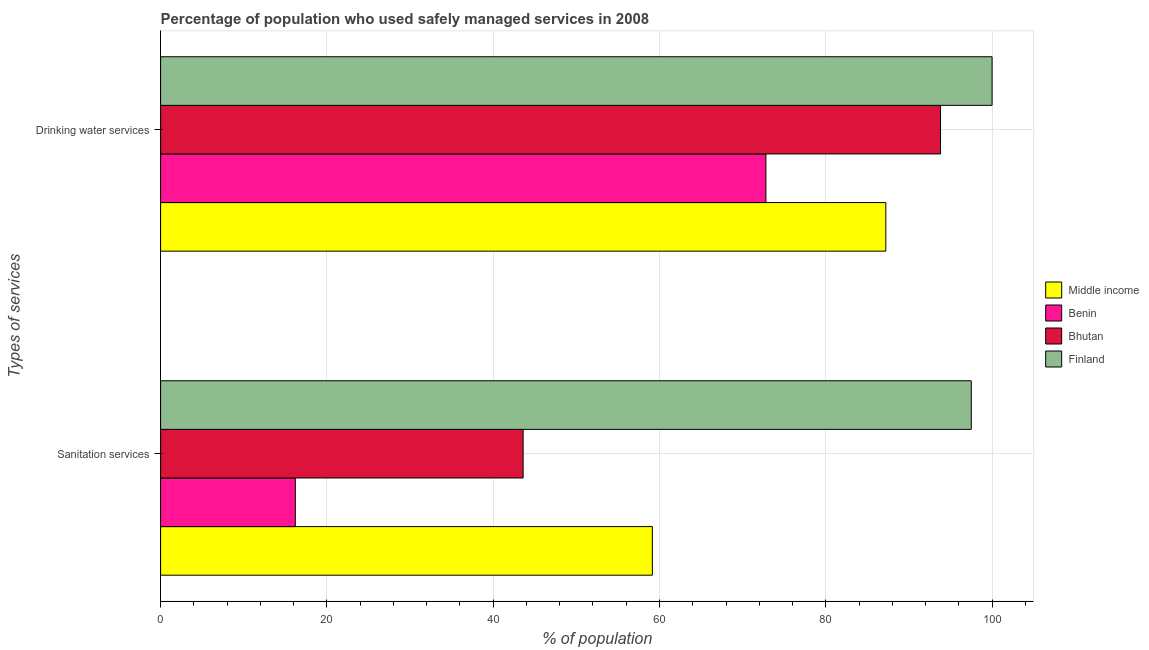How many groups of bars are there?
Give a very brief answer. 2. Are the number of bars per tick equal to the number of legend labels?
Provide a short and direct response. Yes. How many bars are there on the 1st tick from the bottom?
Provide a succinct answer. 4. What is the label of the 2nd group of bars from the top?
Offer a terse response. Sanitation services. What is the percentage of population who used drinking water services in Middle income?
Offer a terse response. 87.22. Across all countries, what is the maximum percentage of population who used sanitation services?
Ensure brevity in your answer.  97.5. In which country was the percentage of population who used sanitation services minimum?
Ensure brevity in your answer.  Benin. What is the total percentage of population who used drinking water services in the graph?
Provide a short and direct response. 353.82. What is the difference between the percentage of population who used drinking water services in Finland and the percentage of population who used sanitation services in Middle income?
Make the answer very short. 40.86. What is the average percentage of population who used drinking water services per country?
Keep it short and to the point. 88.45. What is the difference between the percentage of population who used drinking water services and percentage of population who used sanitation services in Benin?
Make the answer very short. 56.6. In how many countries, is the percentage of population who used sanitation services greater than 12 %?
Make the answer very short. 4. What is the ratio of the percentage of population who used drinking water services in Finland to that in Benin?
Your answer should be compact. 1.37. Is the percentage of population who used drinking water services in Finland less than that in Benin?
Make the answer very short. No. In how many countries, is the percentage of population who used sanitation services greater than the average percentage of population who used sanitation services taken over all countries?
Your answer should be compact. 2. How many bars are there?
Your answer should be very brief. 8. Are all the bars in the graph horizontal?
Your response must be concise. Yes. What is the difference between two consecutive major ticks on the X-axis?
Offer a very short reply. 20. Does the graph contain grids?
Offer a terse response. Yes. How many legend labels are there?
Your answer should be compact. 4. How are the legend labels stacked?
Offer a terse response. Vertical. What is the title of the graph?
Your response must be concise. Percentage of population who used safely managed services in 2008. What is the label or title of the X-axis?
Ensure brevity in your answer.  % of population. What is the label or title of the Y-axis?
Offer a very short reply. Types of services. What is the % of population in Middle income in Sanitation services?
Ensure brevity in your answer.  59.14. What is the % of population of Bhutan in Sanitation services?
Your answer should be compact. 43.6. What is the % of population of Finland in Sanitation services?
Your response must be concise. 97.5. What is the % of population in Middle income in Drinking water services?
Offer a very short reply. 87.22. What is the % of population in Benin in Drinking water services?
Make the answer very short. 72.8. What is the % of population in Bhutan in Drinking water services?
Your answer should be compact. 93.8. Across all Types of services, what is the maximum % of population of Middle income?
Keep it short and to the point. 87.22. Across all Types of services, what is the maximum % of population in Benin?
Make the answer very short. 72.8. Across all Types of services, what is the maximum % of population in Bhutan?
Your answer should be compact. 93.8. Across all Types of services, what is the maximum % of population in Finland?
Your response must be concise. 100. Across all Types of services, what is the minimum % of population in Middle income?
Keep it short and to the point. 59.14. Across all Types of services, what is the minimum % of population in Bhutan?
Your response must be concise. 43.6. Across all Types of services, what is the minimum % of population in Finland?
Keep it short and to the point. 97.5. What is the total % of population in Middle income in the graph?
Offer a terse response. 146.36. What is the total % of population in Benin in the graph?
Offer a terse response. 89. What is the total % of population of Bhutan in the graph?
Keep it short and to the point. 137.4. What is the total % of population in Finland in the graph?
Your response must be concise. 197.5. What is the difference between the % of population of Middle income in Sanitation services and that in Drinking water services?
Offer a terse response. -28.08. What is the difference between the % of population of Benin in Sanitation services and that in Drinking water services?
Make the answer very short. -56.6. What is the difference between the % of population of Bhutan in Sanitation services and that in Drinking water services?
Ensure brevity in your answer.  -50.2. What is the difference between the % of population in Middle income in Sanitation services and the % of population in Benin in Drinking water services?
Give a very brief answer. -13.66. What is the difference between the % of population in Middle income in Sanitation services and the % of population in Bhutan in Drinking water services?
Provide a short and direct response. -34.66. What is the difference between the % of population in Middle income in Sanitation services and the % of population in Finland in Drinking water services?
Provide a short and direct response. -40.86. What is the difference between the % of population in Benin in Sanitation services and the % of population in Bhutan in Drinking water services?
Your answer should be compact. -77.6. What is the difference between the % of population of Benin in Sanitation services and the % of population of Finland in Drinking water services?
Give a very brief answer. -83.8. What is the difference between the % of population of Bhutan in Sanitation services and the % of population of Finland in Drinking water services?
Keep it short and to the point. -56.4. What is the average % of population in Middle income per Types of services?
Your answer should be very brief. 73.18. What is the average % of population of Benin per Types of services?
Keep it short and to the point. 44.5. What is the average % of population in Bhutan per Types of services?
Ensure brevity in your answer.  68.7. What is the average % of population of Finland per Types of services?
Your response must be concise. 98.75. What is the difference between the % of population in Middle income and % of population in Benin in Sanitation services?
Your answer should be compact. 42.94. What is the difference between the % of population of Middle income and % of population of Bhutan in Sanitation services?
Provide a succinct answer. 15.54. What is the difference between the % of population in Middle income and % of population in Finland in Sanitation services?
Keep it short and to the point. -38.36. What is the difference between the % of population in Benin and % of population in Bhutan in Sanitation services?
Offer a very short reply. -27.4. What is the difference between the % of population of Benin and % of population of Finland in Sanitation services?
Keep it short and to the point. -81.3. What is the difference between the % of population of Bhutan and % of population of Finland in Sanitation services?
Ensure brevity in your answer.  -53.9. What is the difference between the % of population in Middle income and % of population in Benin in Drinking water services?
Provide a succinct answer. 14.42. What is the difference between the % of population of Middle income and % of population of Bhutan in Drinking water services?
Your response must be concise. -6.58. What is the difference between the % of population of Middle income and % of population of Finland in Drinking water services?
Your response must be concise. -12.78. What is the difference between the % of population in Benin and % of population in Bhutan in Drinking water services?
Provide a succinct answer. -21. What is the difference between the % of population of Benin and % of population of Finland in Drinking water services?
Ensure brevity in your answer.  -27.2. What is the ratio of the % of population of Middle income in Sanitation services to that in Drinking water services?
Provide a succinct answer. 0.68. What is the ratio of the % of population of Benin in Sanitation services to that in Drinking water services?
Give a very brief answer. 0.22. What is the ratio of the % of population in Bhutan in Sanitation services to that in Drinking water services?
Give a very brief answer. 0.46. What is the difference between the highest and the second highest % of population in Middle income?
Your answer should be very brief. 28.08. What is the difference between the highest and the second highest % of population in Benin?
Your response must be concise. 56.6. What is the difference between the highest and the second highest % of population of Bhutan?
Your response must be concise. 50.2. What is the difference between the highest and the second highest % of population of Finland?
Your answer should be compact. 2.5. What is the difference between the highest and the lowest % of population in Middle income?
Your answer should be very brief. 28.08. What is the difference between the highest and the lowest % of population of Benin?
Offer a terse response. 56.6. What is the difference between the highest and the lowest % of population in Bhutan?
Give a very brief answer. 50.2. What is the difference between the highest and the lowest % of population of Finland?
Give a very brief answer. 2.5. 